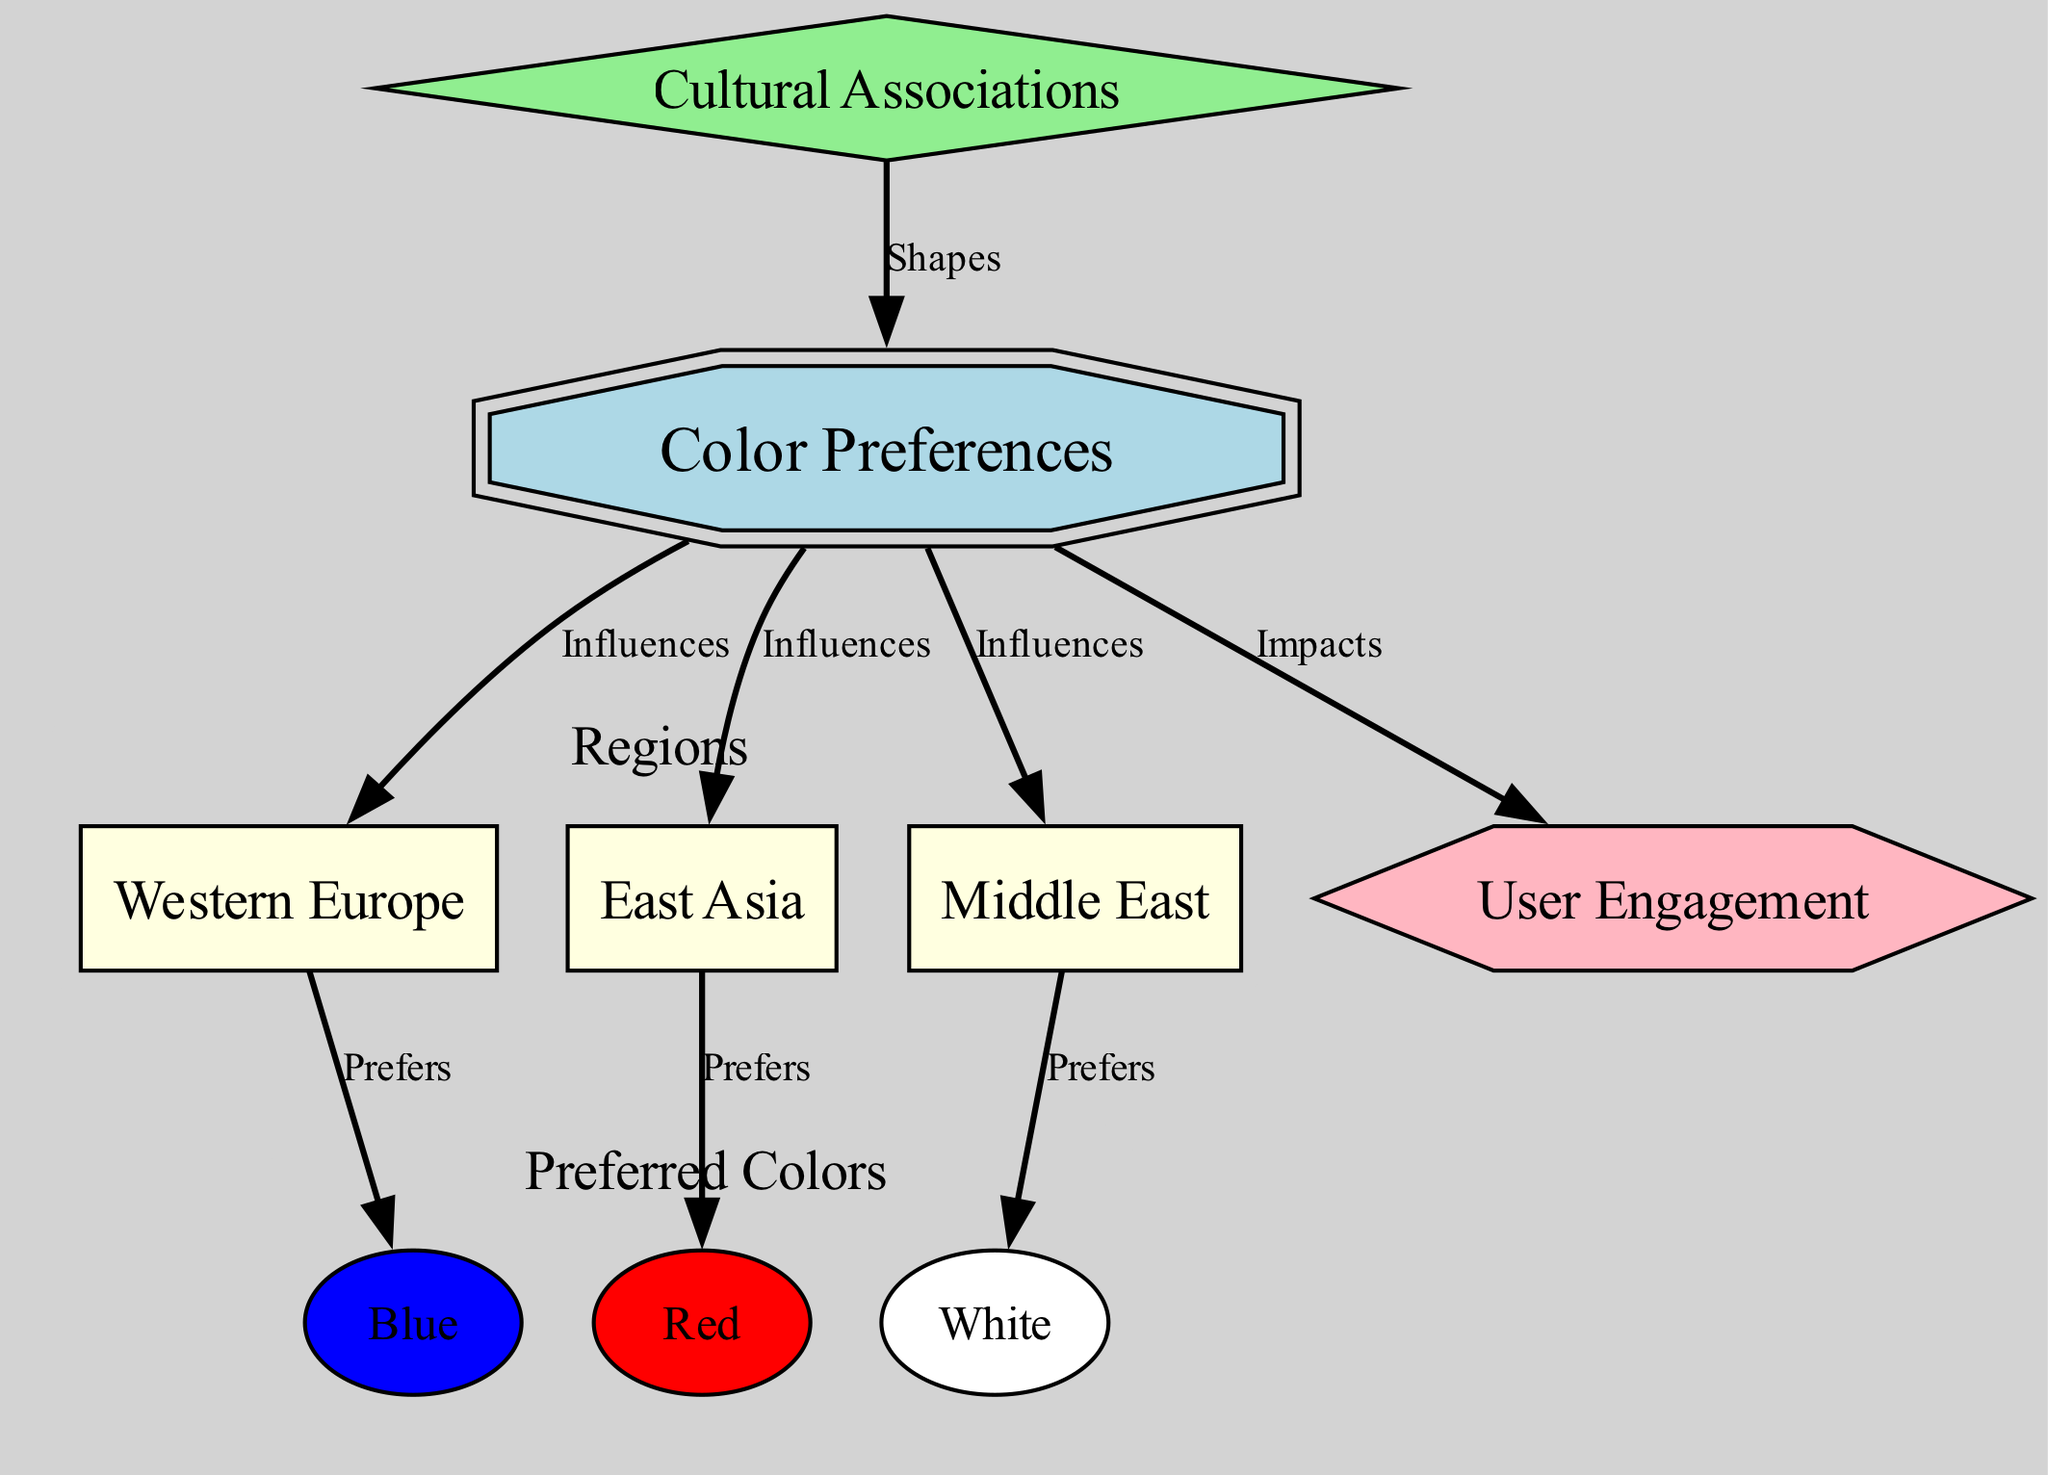What is the central node in the diagram? The central node is labeled "Color Preferences". This is determined by looking for the node with the type "central" in the list of nodes.
Answer: Color Preferences How many regions are represented in the diagram? Three regions are present: Western Europe, East Asia, and Middle East. This can be counted by identifying all the nodes with the type "region".
Answer: 3 Which color is preferred in Western Europe? The preferred color in Western Europe is Blue. This is found by tracing the edge labeled "Prefers" from Western Europe to the color node.
Answer: Blue What influences the color preferences depicted in the diagram? The color preferences are influenced by the regions: Western Europe, East Asia, and Middle East. This can be seen by noting the edges labeled "Influences" connecting the central node to each region.
Answer: Western Europe, East Asia, Middle East What impact does Color Preferences have on User Engagement? Color Preferences impacts User Engagement. This is observed by following the edge labeled "Impacts" from the central node "Color Preferences" to the metric node "User Engagement".
Answer: Impacts Which color is preferred in East Asia? The preferred color in East Asia is Red. This is identified by the edge indicating preference from East Asia to the color node Red.
Answer: Red What is the shape of the node representing Cultural Associations? The node for Cultural Associations has a diamond shape. This is determined by checking the node styles assigned based on the type of node "factor".
Answer: Diamond What metric does the diagram illustrate as being affected by color preferences? The diagram illustrates that User Engagement is affected by color preferences. This is determined by following the edge labeled "Impacts" from Color Preferences to User Engagement.
Answer: User Engagement 